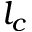Convert formula to latex. <formula><loc_0><loc_0><loc_500><loc_500>l _ { c }</formula> 